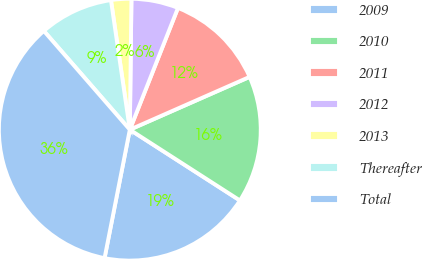Convert chart. <chart><loc_0><loc_0><loc_500><loc_500><pie_chart><fcel>2009<fcel>2010<fcel>2011<fcel>2012<fcel>2013<fcel>Thereafter<fcel>Total<nl><fcel>19.0%<fcel>15.7%<fcel>12.4%<fcel>5.8%<fcel>2.5%<fcel>9.1%<fcel>35.51%<nl></chart> 